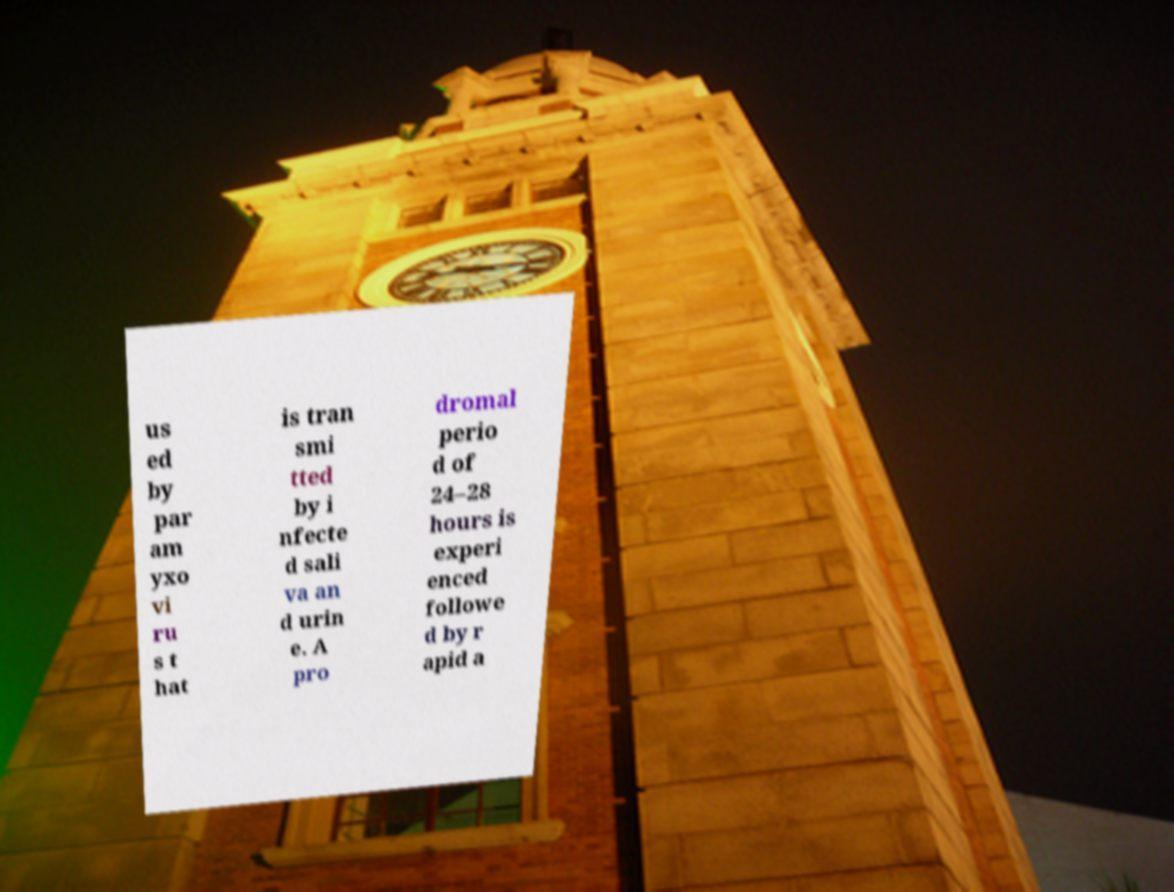Please identify and transcribe the text found in this image. us ed by par am yxo vi ru s t hat is tran smi tted by i nfecte d sali va an d urin e. A pro dromal perio d of 24–28 hours is experi enced followe d by r apid a 